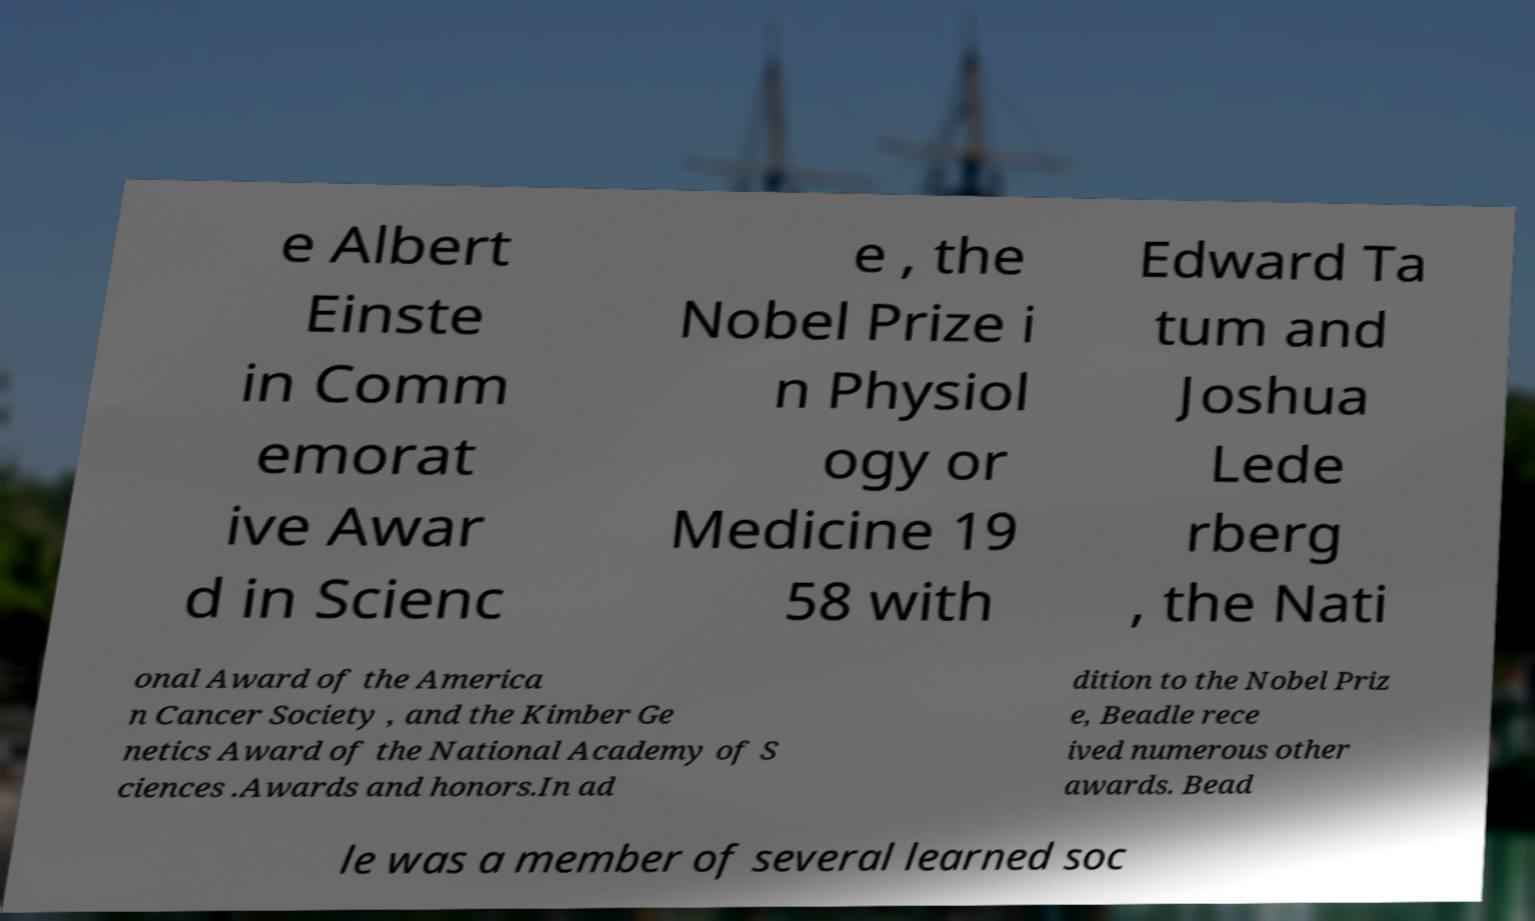Could you extract and type out the text from this image? e Albert Einste in Comm emorat ive Awar d in Scienc e , the Nobel Prize i n Physiol ogy or Medicine 19 58 with Edward Ta tum and Joshua Lede rberg , the Nati onal Award of the America n Cancer Society , and the Kimber Ge netics Award of the National Academy of S ciences .Awards and honors.In ad dition to the Nobel Priz e, Beadle rece ived numerous other awards. Bead le was a member of several learned soc 